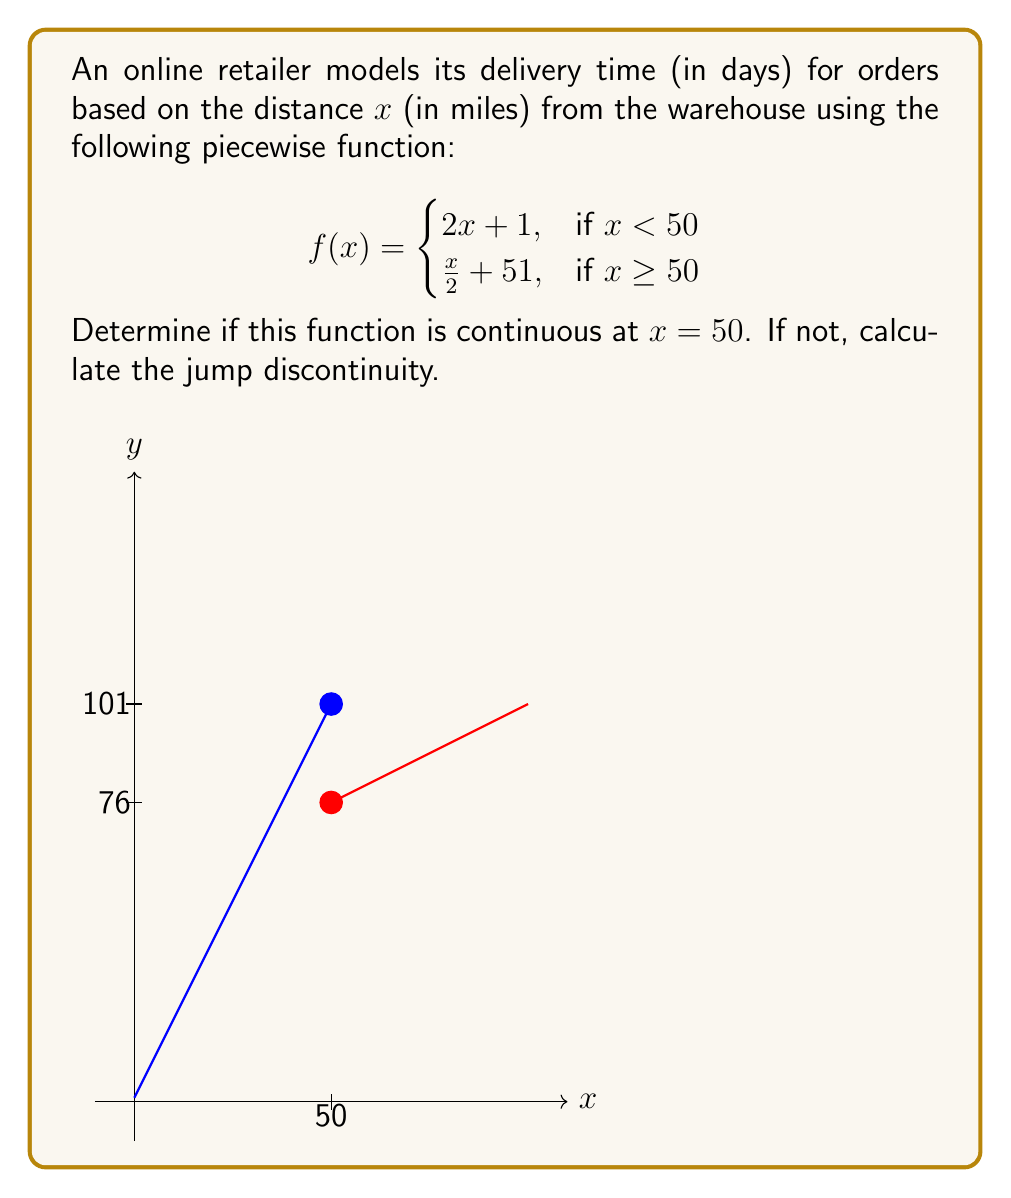What is the answer to this math problem? To determine if the function is continuous at $x = 50$, we need to check three conditions:
1. $f(50)$ exists
2. $\lim_{x \to 50^-} f(x)$ exists
3. $\lim_{x \to 50^+} f(x)$ exists
4. All three values are equal

Step 1: Calculate $f(50)$
Since $x \geq 50$, we use the second piece of the function:
$f(50) = \frac{50}{2} + 51 = 25 + 51 = 76$

Step 2: Calculate $\lim_{x \to 50^-} f(x)$
As we approach 50 from the left, we use the first piece of the function:
$\lim_{x \to 50^-} f(x) = \lim_{x \to 50^-} (2x + 1) = 2(50) + 1 = 101$

Step 3: Calculate $\lim_{x \to 50^+} f(x)$
As we approach 50 from the right, we use the second piece of the function:
$\lim_{x \to 50^+} f(x) = \lim_{x \to 50^+} (\frac{x}{2} + 51) = \frac{50}{2} + 51 = 76$

Step 4: Compare the values
We can see that:
$f(50) = 76$
$\lim_{x \to 50^-} f(x) = 101$
$\lim_{x \to 50^+} f(x) = 76$

Since these values are not all equal, the function is not continuous at $x = 50$.

Step 5: Calculate the jump discontinuity
The jump discontinuity is the difference between the left-hand limit and the right-hand limit:
Jump discontinuity $= \lim_{x \to 50^-} f(x) - \lim_{x \to 50^+} f(x) = 101 - 76 = 25$
Answer: Not continuous; jump discontinuity = 25 